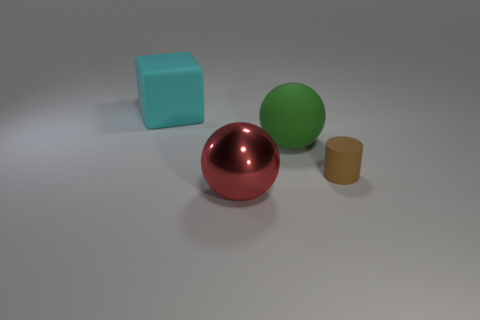Is there anything else that has the same material as the big red sphere?
Provide a short and direct response. No. Are there any small brown cylinders made of the same material as the big red object?
Ensure brevity in your answer.  No. There is a large rubber thing right of the big matte thing that is on the left side of the large rubber thing on the right side of the cyan rubber object; what shape is it?
Provide a succinct answer. Sphere. What is the large red sphere made of?
Offer a terse response. Metal. There is a cylinder that is the same material as the cyan block; what color is it?
Provide a succinct answer. Brown. There is a big sphere in front of the small brown rubber object; are there any objects right of it?
Give a very brief answer. Yes. How many other objects are there of the same shape as the large red thing?
Your answer should be very brief. 1. Do the large red thing in front of the cylinder and the large thing on the left side of the big red ball have the same shape?
Offer a terse response. No. There is a large rubber thing that is to the left of the object in front of the brown thing; how many big red metallic things are right of it?
Give a very brief answer. 1. The big matte block has what color?
Offer a very short reply. Cyan. 